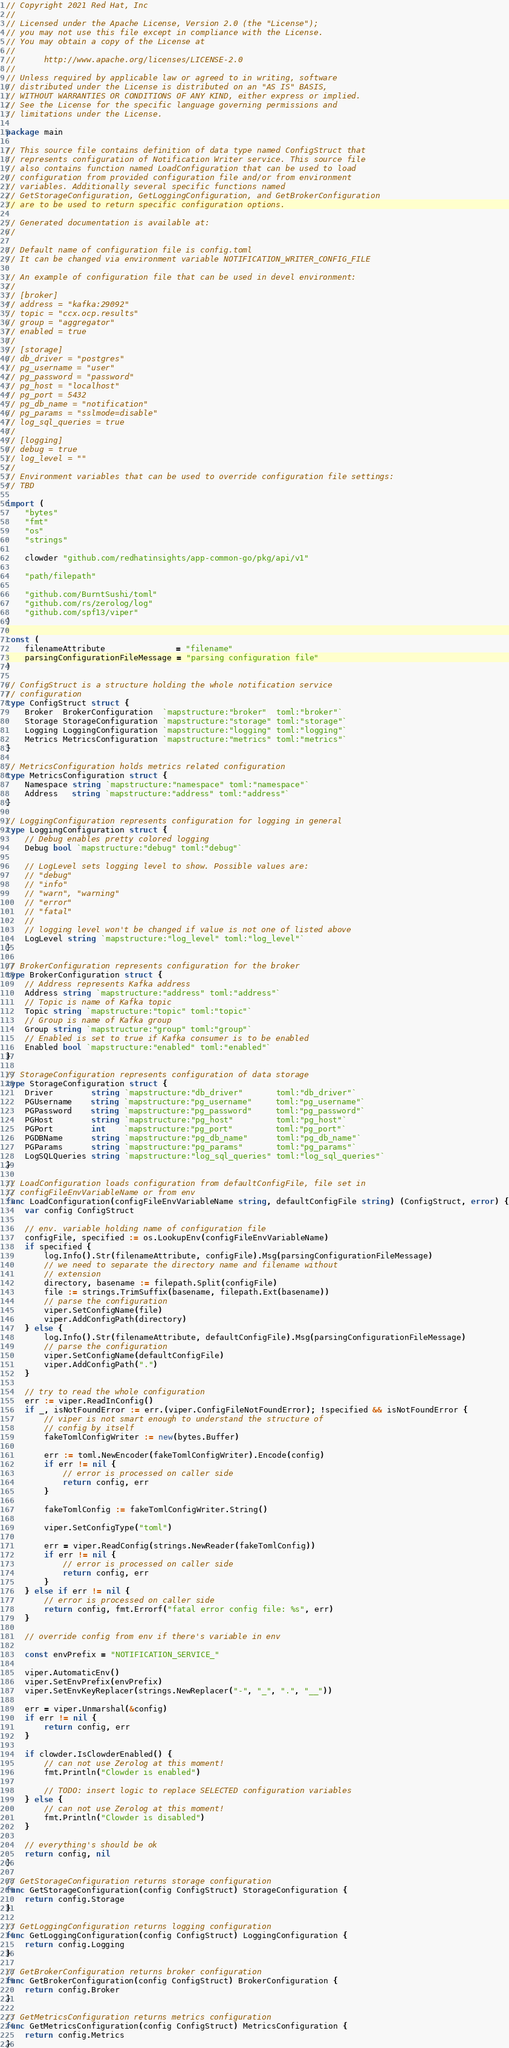Convert code to text. <code><loc_0><loc_0><loc_500><loc_500><_Go_>// Copyright 2021 Red Hat, Inc
//
// Licensed under the Apache License, Version 2.0 (the "License");
// you may not use this file except in compliance with the License.
// You may obtain a copy of the License at
//
//      http://www.apache.org/licenses/LICENSE-2.0
//
// Unless required by applicable law or agreed to in writing, software
// distributed under the License is distributed on an "AS IS" BASIS,
// WITHOUT WARRANTIES OR CONDITIONS OF ANY KIND, either express or implied.
// See the License for the specific language governing permissions and
// limitations under the License.

package main

// This source file contains definition of data type named ConfigStruct that
// represents configuration of Notification Writer service. This source file
// also contains function named LoadConfiguration that can be used to load
// configuration from provided configuration file and/or from environment
// variables. Additionally several specific functions named
// GetStorageConfiguration, GetLoggingConfiguration, and GetBrokerConfiguration
// are to be used to return specific configuration options.

// Generated documentation is available at:
//

// Default name of configuration file is config.toml
// It can be changed via environment variable NOTIFICATION_WRITER_CONFIG_FILE

// An example of configuration file that can be used in devel environment:
//
// [broker]
// address = "kafka:29092"
// topic = "ccx.ocp.results"
// group = "aggregator"
// enabled = true
//
// [storage]
// db_driver = "postgres"
// pg_username = "user"
// pg_password = "password"
// pg_host = "localhost"
// pg_port = 5432
// pg_db_name = "notification"
// pg_params = "sslmode=disable"
// log_sql_queries = true
//
// [logging]
// debug = true
// log_level = ""
//
// Environment variables that can be used to override configuration file settings:
// TBD

import (
	"bytes"
	"fmt"
	"os"
	"strings"

	clowder "github.com/redhatinsights/app-common-go/pkg/api/v1"

	"path/filepath"

	"github.com/BurntSushi/toml"
	"github.com/rs/zerolog/log"
	"github.com/spf13/viper"
)

const (
	filenameAttribute               = "filename"
	parsingConfigurationFileMessage = "parsing configuration file"
)

// ConfigStruct is a structure holding the whole notification service
// configuration
type ConfigStruct struct {
	Broker  BrokerConfiguration  `mapstructure:"broker"  toml:"broker"`
	Storage StorageConfiguration `mapstructure:"storage" toml:"storage"`
	Logging LoggingConfiguration `mapstructure:"logging" toml:"logging"`
	Metrics MetricsConfiguration `mapstructure:"metrics" toml:"metrics"`
}

// MetricsConfiguration holds metrics related configuration
type MetricsConfiguration struct {
	Namespace string `mapstructure:"namespace" toml:"namespace"`
	Address   string `mapstructure:"address" toml:"address"`
}

// LoggingConfiguration represents configuration for logging in general
type LoggingConfiguration struct {
	// Debug enables pretty colored logging
	Debug bool `mapstructure:"debug" toml:"debug"`

	// LogLevel sets logging level to show. Possible values are:
	// "debug"
	// "info"
	// "warn", "warning"
	// "error"
	// "fatal"
	//
	// logging level won't be changed if value is not one of listed above
	LogLevel string `mapstructure:"log_level" toml:"log_level"`
}

// BrokerConfiguration represents configuration for the broker
type BrokerConfiguration struct {
	// Address represents Kafka address
	Address string `mapstructure:"address" toml:"address"`
	// Topic is name of Kafka topic
	Topic string `mapstructure:"topic" toml:"topic"`
	// Group is name of Kafka group
	Group string `mapstructure:"group" toml:"group"`
	// Enabled is set to true if Kafka consumer is to be enabled
	Enabled bool `mapstructure:"enabled" toml:"enabled"`
}

// StorageConfiguration represents configuration of data storage
type StorageConfiguration struct {
	Driver        string `mapstructure:"db_driver"       toml:"db_driver"`
	PGUsername    string `mapstructure:"pg_username"     toml:"pg_username"`
	PGPassword    string `mapstructure:"pg_password"     toml:"pg_password"`
	PGHost        string `mapstructure:"pg_host"         toml:"pg_host"`
	PGPort        int    `mapstructure:"pg_port"         toml:"pg_port"`
	PGDBName      string `mapstructure:"pg_db_name"      toml:"pg_db_name"`
	PGParams      string `mapstructure:"pg_params"       toml:"pg_params"`
	LogSQLQueries string `mapstructure:"log_sql_queries" toml:"log_sql_queries"`
}

// LoadConfiguration loads configuration from defaultConfigFile, file set in
// configFileEnvVariableName or from env
func LoadConfiguration(configFileEnvVariableName string, defaultConfigFile string) (ConfigStruct, error) {
	var config ConfigStruct

	// env. variable holding name of configuration file
	configFile, specified := os.LookupEnv(configFileEnvVariableName)
	if specified {
		log.Info().Str(filenameAttribute, configFile).Msg(parsingConfigurationFileMessage)
		// we need to separate the directory name and filename without
		// extension
		directory, basename := filepath.Split(configFile)
		file := strings.TrimSuffix(basename, filepath.Ext(basename))
		// parse the configuration
		viper.SetConfigName(file)
		viper.AddConfigPath(directory)
	} else {
		log.Info().Str(filenameAttribute, defaultConfigFile).Msg(parsingConfigurationFileMessage)
		// parse the configuration
		viper.SetConfigName(defaultConfigFile)
		viper.AddConfigPath(".")
	}

	// try to read the whole configuration
	err := viper.ReadInConfig()
	if _, isNotFoundError := err.(viper.ConfigFileNotFoundError); !specified && isNotFoundError {
		// viper is not smart enough to understand the structure of
		// config by itself
		fakeTomlConfigWriter := new(bytes.Buffer)

		err := toml.NewEncoder(fakeTomlConfigWriter).Encode(config)
		if err != nil {
			// error is processed on caller side
			return config, err
		}

		fakeTomlConfig := fakeTomlConfigWriter.String()

		viper.SetConfigType("toml")

		err = viper.ReadConfig(strings.NewReader(fakeTomlConfig))
		if err != nil {
			// error is processed on caller side
			return config, err
		}
	} else if err != nil {
		// error is processed on caller side
		return config, fmt.Errorf("fatal error config file: %s", err)
	}

	// override config from env if there's variable in env

	const envPrefix = "NOTIFICATION_SERVICE_"

	viper.AutomaticEnv()
	viper.SetEnvPrefix(envPrefix)
	viper.SetEnvKeyReplacer(strings.NewReplacer("-", "_", ".", "__"))

	err = viper.Unmarshal(&config)
	if err != nil {
		return config, err
	}

	if clowder.IsClowderEnabled() {
		// can not use Zerolog at this moment!
		fmt.Println("Clowder is enabled")

		// TODO: insert logic to replace SELECTED configuration variables
	} else {
		// can not use Zerolog at this moment!
		fmt.Println("Clowder is disabled")
	}

	// everything's should be ok
	return config, nil
}

// GetStorageConfiguration returns storage configuration
func GetStorageConfiguration(config ConfigStruct) StorageConfiguration {
	return config.Storage
}

// GetLoggingConfiguration returns logging configuration
func GetLoggingConfiguration(config ConfigStruct) LoggingConfiguration {
	return config.Logging
}

// GetBrokerConfiguration returns broker configuration
func GetBrokerConfiguration(config ConfigStruct) BrokerConfiguration {
	return config.Broker
}

// GetMetricsConfiguration returns metrics configuration
func GetMetricsConfiguration(config ConfigStruct) MetricsConfiguration {
	return config.Metrics
}
</code> 